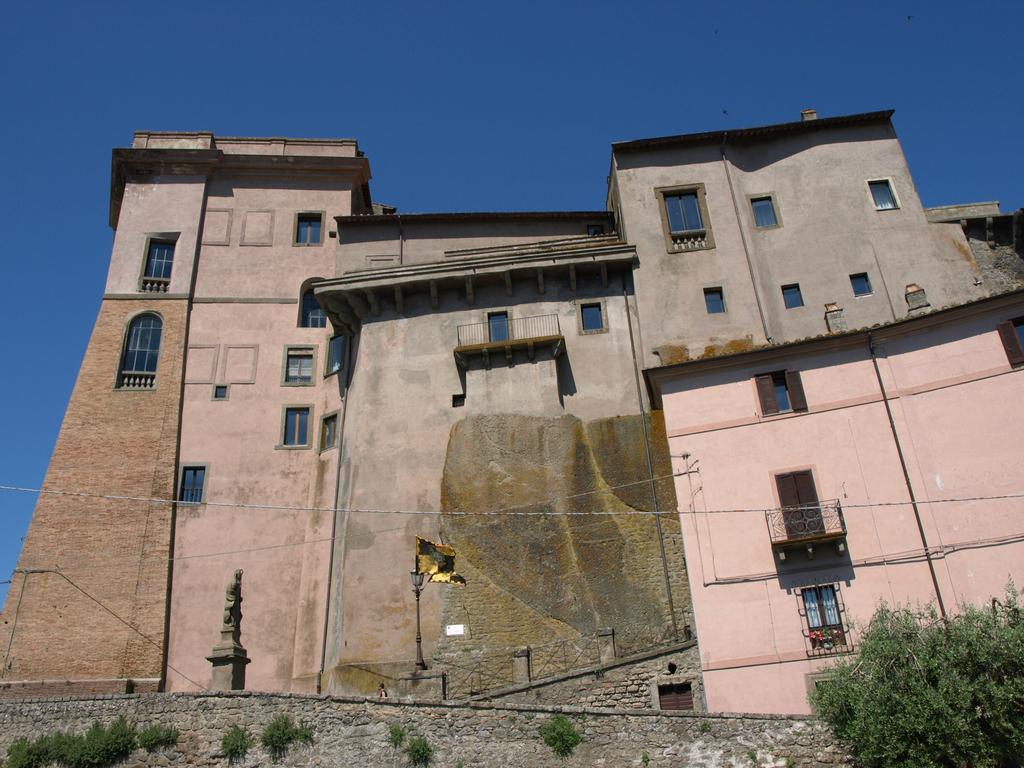Can you describe this image briefly? At the bottom of the picture, we see the shrubs and a wall which is made up of stones. In the right bottom, we see a tree. Behind the wall, we see the statue. In the middle of the picture, we see the buildings in brown, pink and grey color. Beside that, we see poles, light pole and wires. At the top, we see the sky, which is blue in color. 